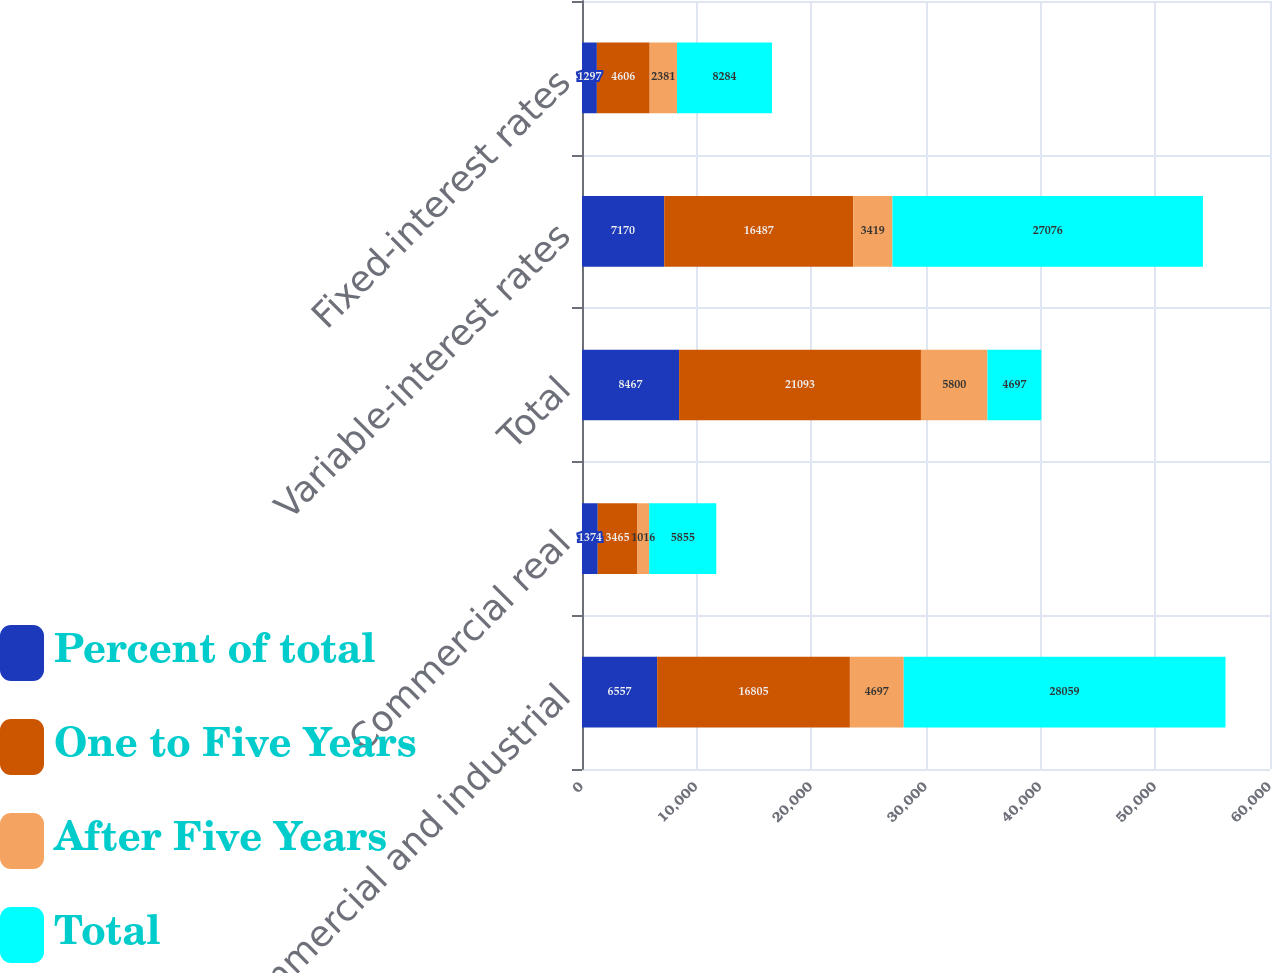Convert chart to OTSL. <chart><loc_0><loc_0><loc_500><loc_500><stacked_bar_chart><ecel><fcel>Commercial and industrial<fcel>Commercial real<fcel>Total<fcel>Variable-interest rates<fcel>Fixed-interest rates<nl><fcel>Percent of total<fcel>6557<fcel>1374<fcel>8467<fcel>7170<fcel>1297<nl><fcel>One to Five Years<fcel>16805<fcel>3465<fcel>21093<fcel>16487<fcel>4606<nl><fcel>After Five Years<fcel>4697<fcel>1016<fcel>5800<fcel>3419<fcel>2381<nl><fcel>Total<fcel>28059<fcel>5855<fcel>4697<fcel>27076<fcel>8284<nl></chart> 